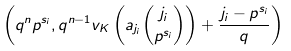Convert formula to latex. <formula><loc_0><loc_0><loc_500><loc_500>\left ( q ^ { n } p ^ { s _ { i } } , q ^ { n - 1 } v _ { K } \left ( a _ { j _ { i } } { { j _ { i } } \choose { p ^ { s _ { i } } } } \right ) + \frac { j _ { i } - p ^ { s _ { i } } } { q } \right )</formula> 